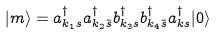<formula> <loc_0><loc_0><loc_500><loc_500>| m \rangle = a ^ { \dagger } _ { k _ { 1 } s } a ^ { \dagger } _ { k _ { 2 } \bar { s } } b ^ { \dagger } _ { k _ { 3 } s } b ^ { \dagger } _ { k _ { 4 } \bar { s } } a ^ { \dagger } _ { k s } | 0 \rangle</formula> 